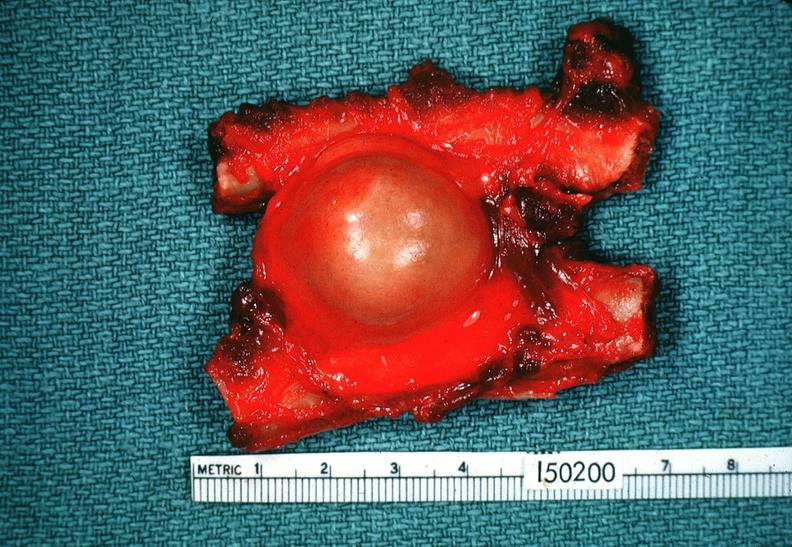does aldehyde fuscin show schwannoma?
Answer the question using a single word or phrase. No 